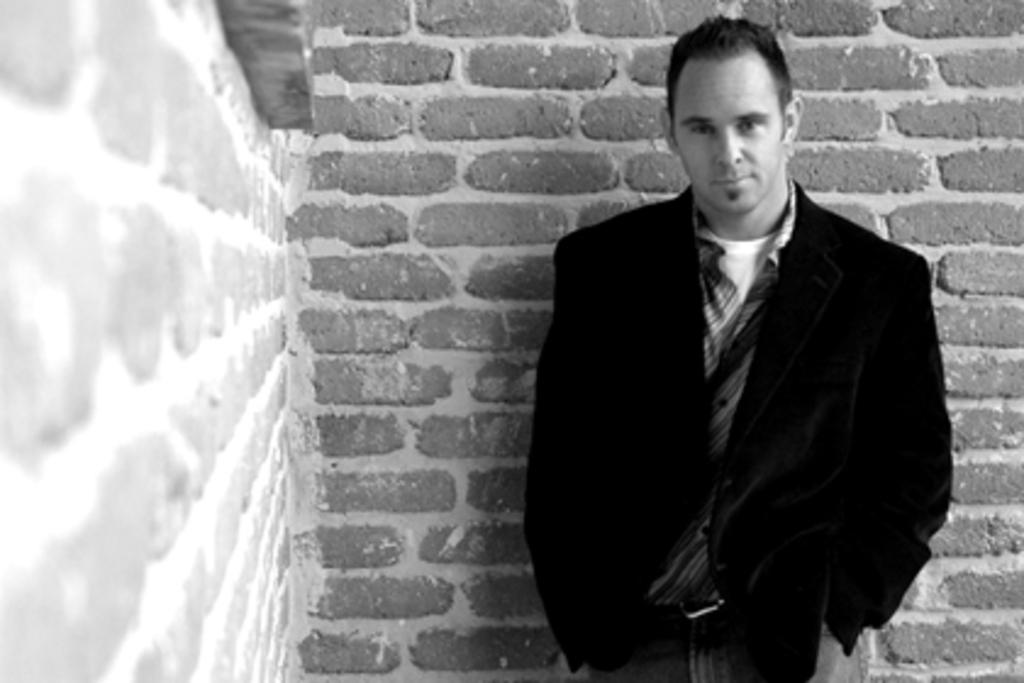Who is present in the image? There is a man standing in the image. What can be seen behind the man? There is a brick wall in the image. What type of vacation is the man planning in the image? There is no indication of a vacation in the image; it only shows a man standing in front of a brick wall. 